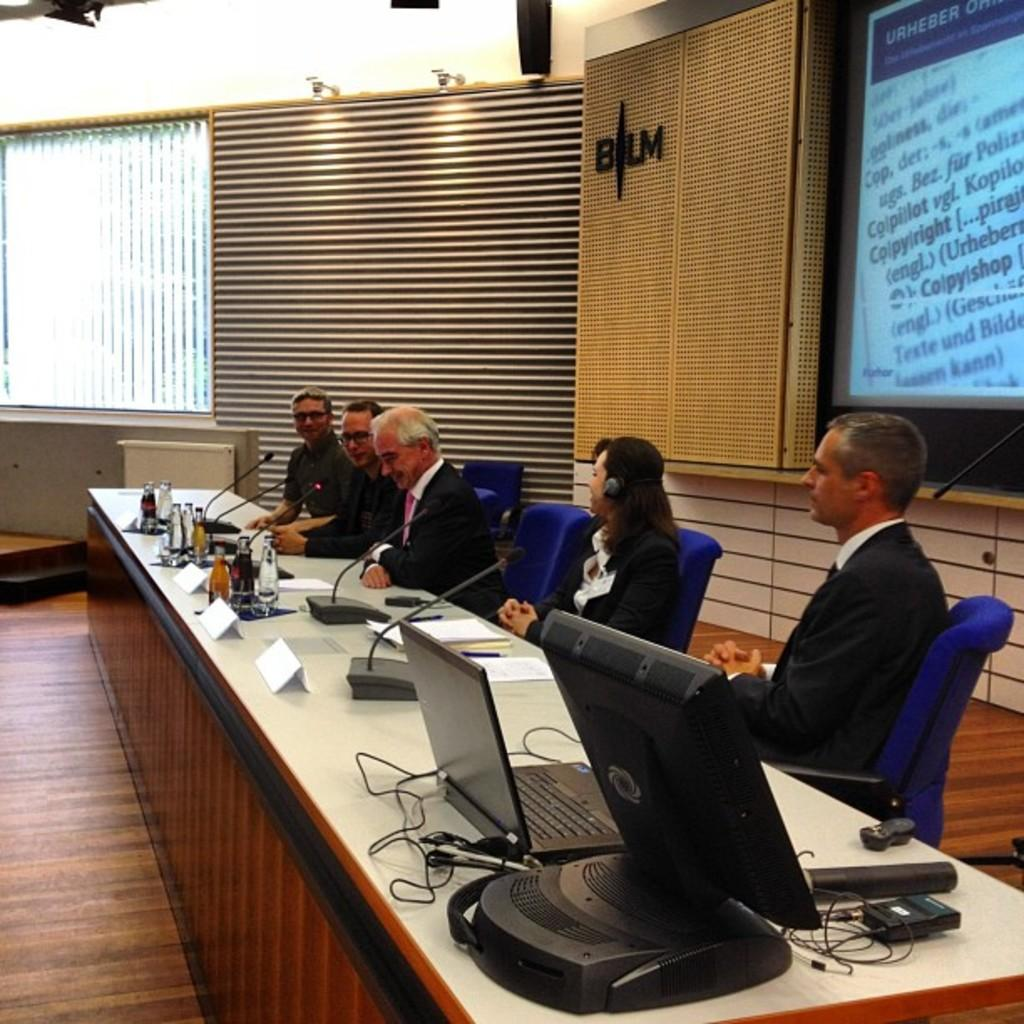<image>
Write a terse but informative summary of the picture. panel of people  sitting in front of a wall with a large display and a b/lm logo at end of wall 